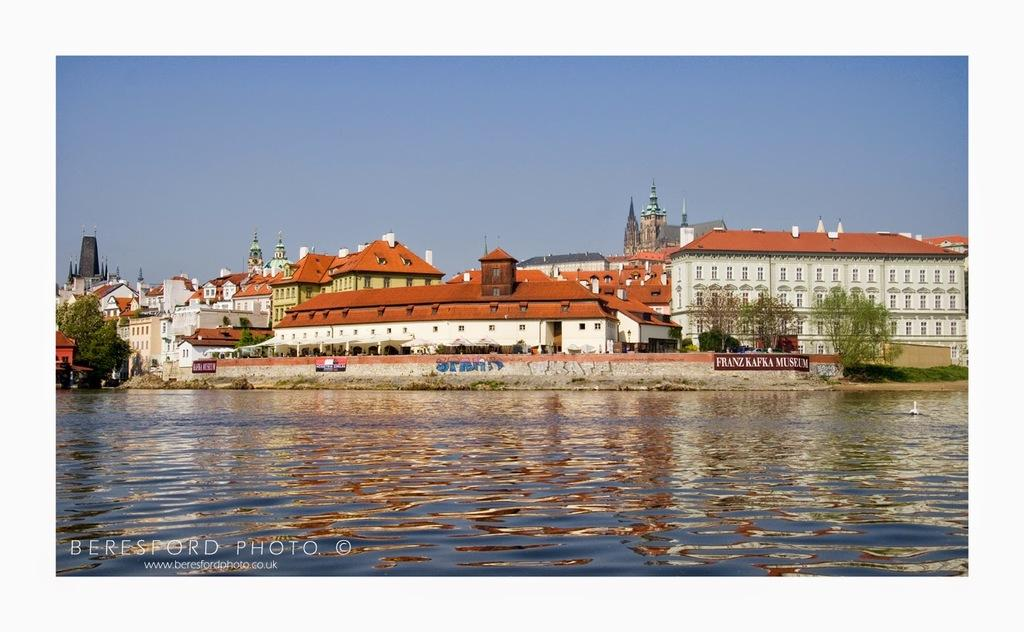What is located in the center of the image? There are buildings in the center of the image. What type of natural elements can be seen in the image? Trees are present in the image. What objects are visible in the image that might be used for displaying information or advertisements? Boards are visible in the image. What type of structure can be seen in the image that might provide privacy or security? There is a wall in the image. What architectural feature is present in the buildings that allows light and air to enter? Windows are present in the image. What is at the bottom of the image? Water is at the bottom of the image. What is visible at the top of the image? The sky is visible at the top of the image. How many cars are parked near the water in the image? There are no cars present in the image. What type of impulse can be seen affecting the trees in the image? There is no impulse affecting the trees in the image; they are stationary. 